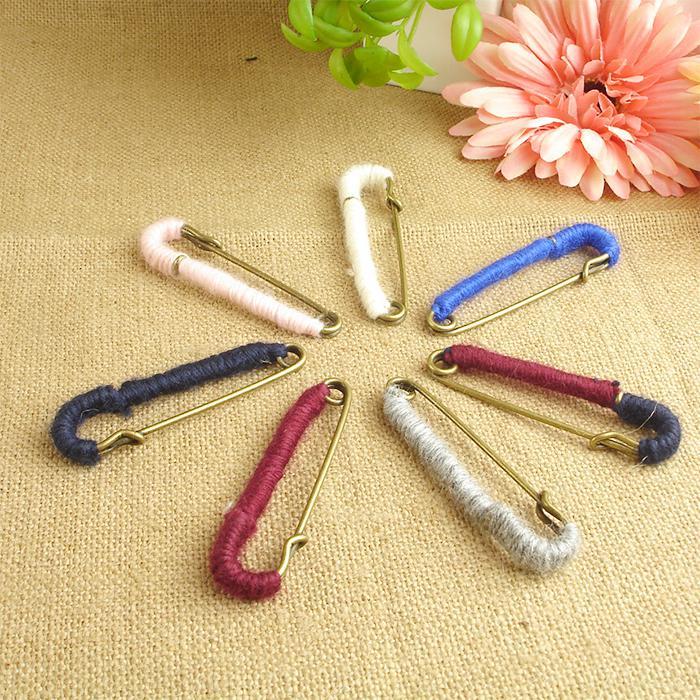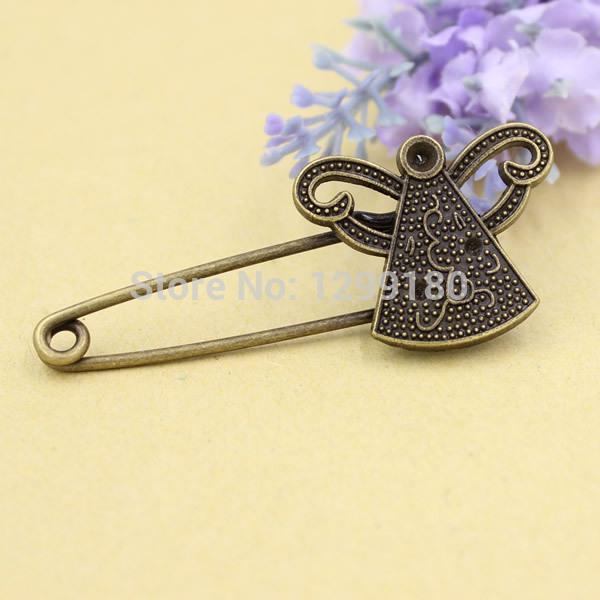The first image is the image on the left, the second image is the image on the right. Given the left and right images, does the statement "Each photo contains a single safety pin with a decorative clasp." hold true? Answer yes or no. No. 